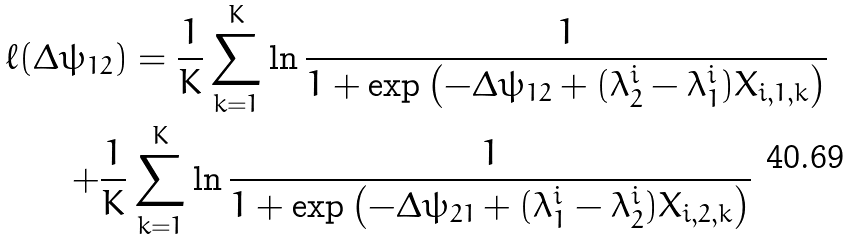<formula> <loc_0><loc_0><loc_500><loc_500>\ell ( \Delta \psi _ { 1 2 } ) & = \frac { 1 } { K } \sum _ { k = 1 } ^ { K } \ln \frac { 1 } { 1 + \exp \left ( - \Delta \psi _ { 1 2 } + ( \lambda ^ { i } _ { 2 } - \lambda ^ { i } _ { 1 } ) X _ { i , 1 , k } \right ) } \\ + \frac { 1 } { K } & \sum _ { k = 1 } ^ { K } \ln \frac { 1 } { 1 + \exp \left ( - \Delta \psi _ { 2 1 } + ( \lambda ^ { i } _ { 1 } - \lambda ^ { i } _ { 2 } ) X _ { i , 2 , k } \right ) }</formula> 